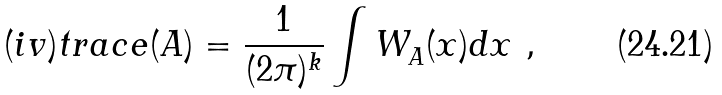Convert formula to latex. <formula><loc_0><loc_0><loc_500><loc_500>{ ( i v ) } t r a c e ( A ) = \frac { 1 } { ( 2 \pi { } ) ^ { k } } \int W ^ { } _ { A } ( x ) d x \ ,</formula> 